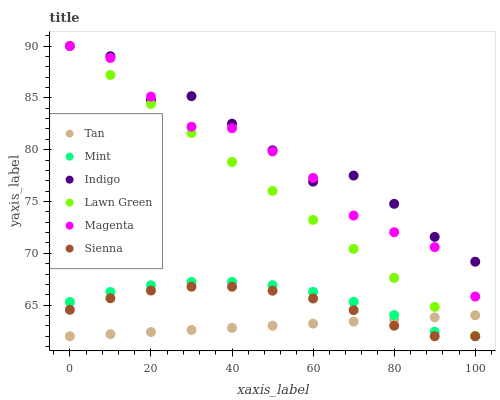Does Tan have the minimum area under the curve?
Answer yes or no. Yes. Does Indigo have the maximum area under the curve?
Answer yes or no. Yes. Does Sienna have the minimum area under the curve?
Answer yes or no. No. Does Sienna have the maximum area under the curve?
Answer yes or no. No. Is Tan the smoothest?
Answer yes or no. Yes. Is Indigo the roughest?
Answer yes or no. Yes. Is Sienna the smoothest?
Answer yes or no. No. Is Sienna the roughest?
Answer yes or no. No. Does Sienna have the lowest value?
Answer yes or no. Yes. Does Indigo have the lowest value?
Answer yes or no. No. Does Magenta have the highest value?
Answer yes or no. Yes. Does Sienna have the highest value?
Answer yes or no. No. Is Tan less than Indigo?
Answer yes or no. Yes. Is Magenta greater than Tan?
Answer yes or no. Yes. Does Tan intersect Sienna?
Answer yes or no. Yes. Is Tan less than Sienna?
Answer yes or no. No. Is Tan greater than Sienna?
Answer yes or no. No. Does Tan intersect Indigo?
Answer yes or no. No. 